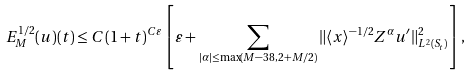Convert formula to latex. <formula><loc_0><loc_0><loc_500><loc_500>E _ { M } ^ { 1 / 2 } ( u ) ( t ) \leq C ( 1 + t ) ^ { C \varepsilon } \left [ \varepsilon + \sum _ { | \alpha | \leq \max ( M - 3 8 , 2 + M / 2 ) } \| \langle x \rangle ^ { - 1 / 2 } Z ^ { \alpha } u ^ { \prime } \| ^ { 2 } _ { L ^ { 2 } ( S _ { t } ) } \right ] ,</formula> 